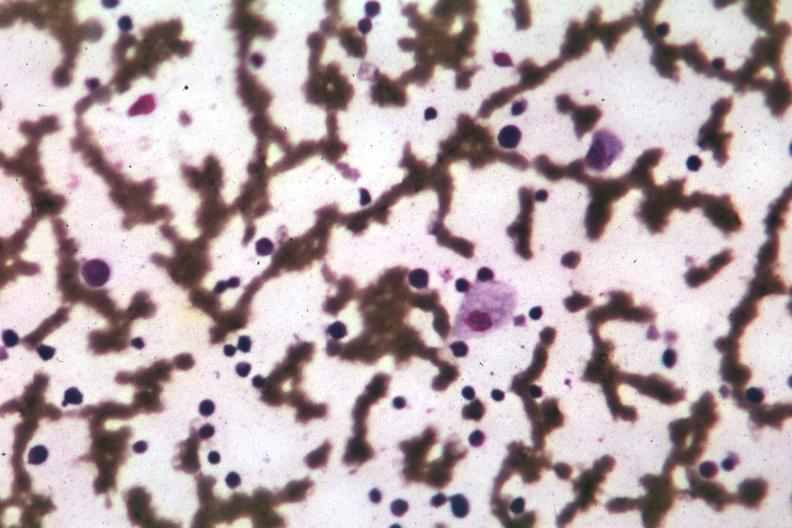what is present?
Answer the question using a single word or phrase. Hematologic 